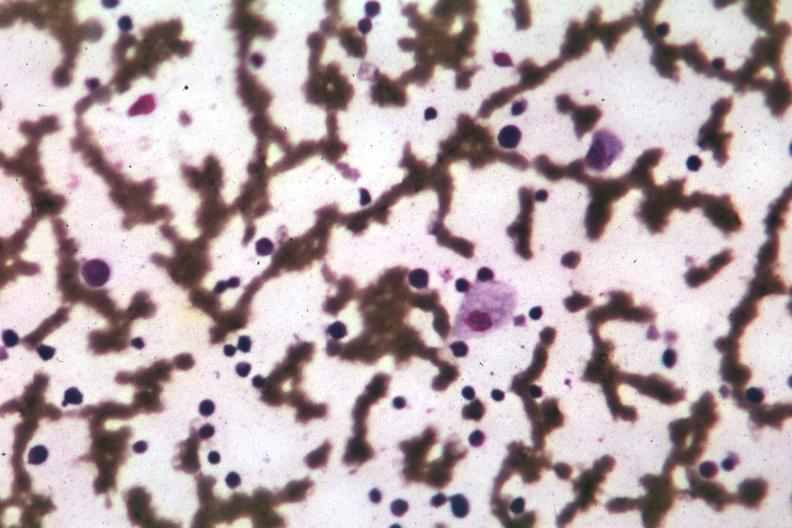what is present?
Answer the question using a single word or phrase. Hematologic 